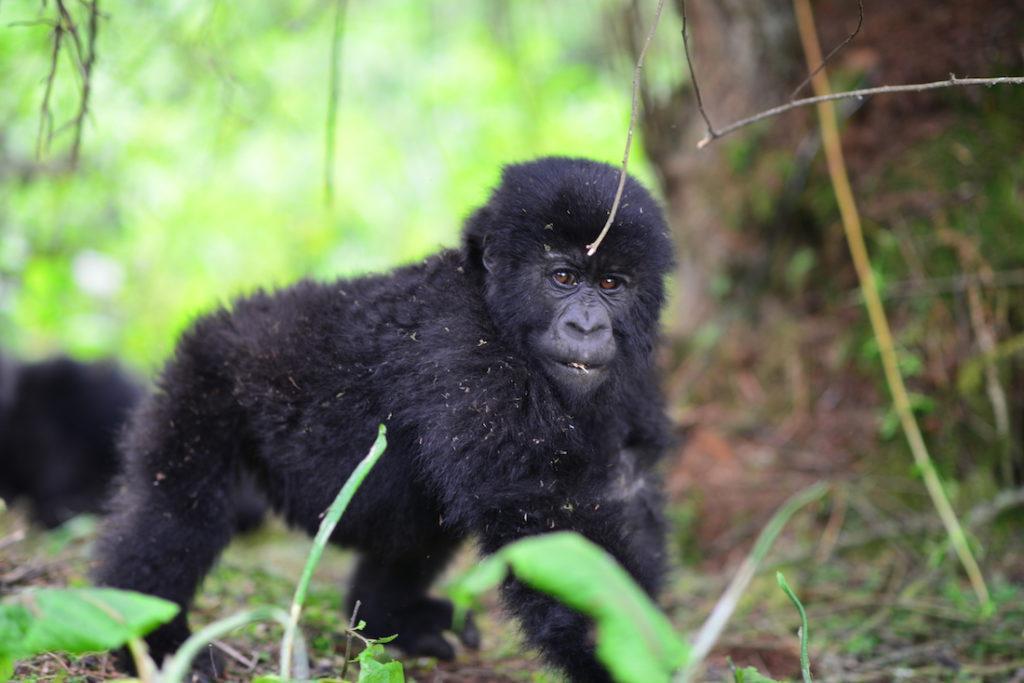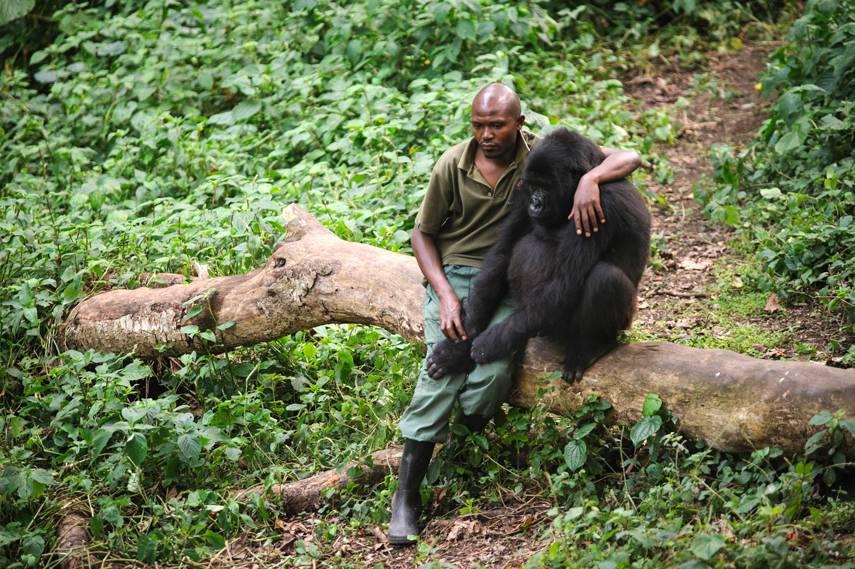The first image is the image on the left, the second image is the image on the right. Examine the images to the left and right. Is the description "The right image contains no more than one gorilla." accurate? Answer yes or no. Yes. The first image is the image on the left, the second image is the image on the right. Examine the images to the left and right. Is the description "A camera-facing person is holding a notebook and standing near a group of gorillas in a forest." accurate? Answer yes or no. No. 